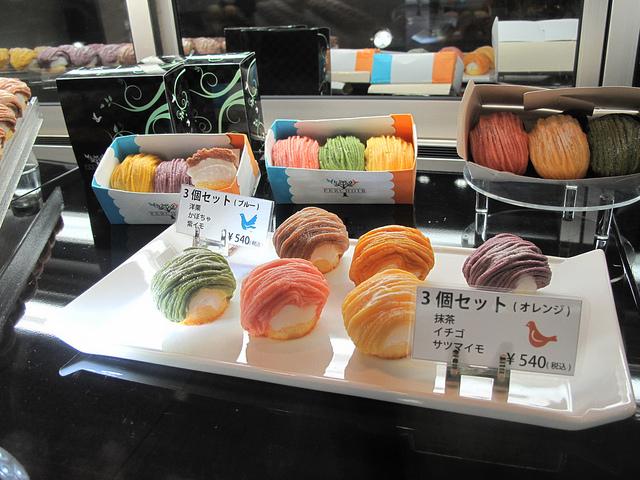Could these be desserts?
Keep it brief. Yes. Is this inside?
Short answer required. Yes. How many pink donuts are there?
Short answer required. 3. How many yen does a box of desserts cost?
Write a very short answer. 540. 